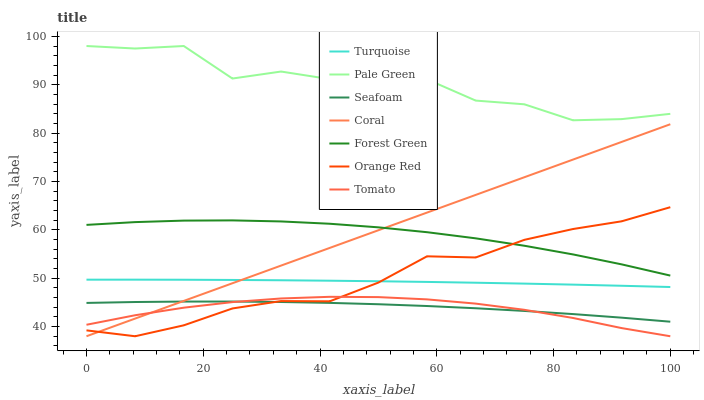Does Tomato have the minimum area under the curve?
Answer yes or no. Yes. Does Pale Green have the maximum area under the curve?
Answer yes or no. Yes. Does Turquoise have the minimum area under the curve?
Answer yes or no. No. Does Turquoise have the maximum area under the curve?
Answer yes or no. No. Is Coral the smoothest?
Answer yes or no. Yes. Is Pale Green the roughest?
Answer yes or no. Yes. Is Turquoise the smoothest?
Answer yes or no. No. Is Turquoise the roughest?
Answer yes or no. No. Does Turquoise have the lowest value?
Answer yes or no. No. Does Pale Green have the highest value?
Answer yes or no. Yes. Does Turquoise have the highest value?
Answer yes or no. No. Is Tomato less than Pale Green?
Answer yes or no. Yes. Is Pale Green greater than Coral?
Answer yes or no. Yes. Does Orange Red intersect Forest Green?
Answer yes or no. Yes. Is Orange Red less than Forest Green?
Answer yes or no. No. Is Orange Red greater than Forest Green?
Answer yes or no. No. Does Tomato intersect Pale Green?
Answer yes or no. No. 